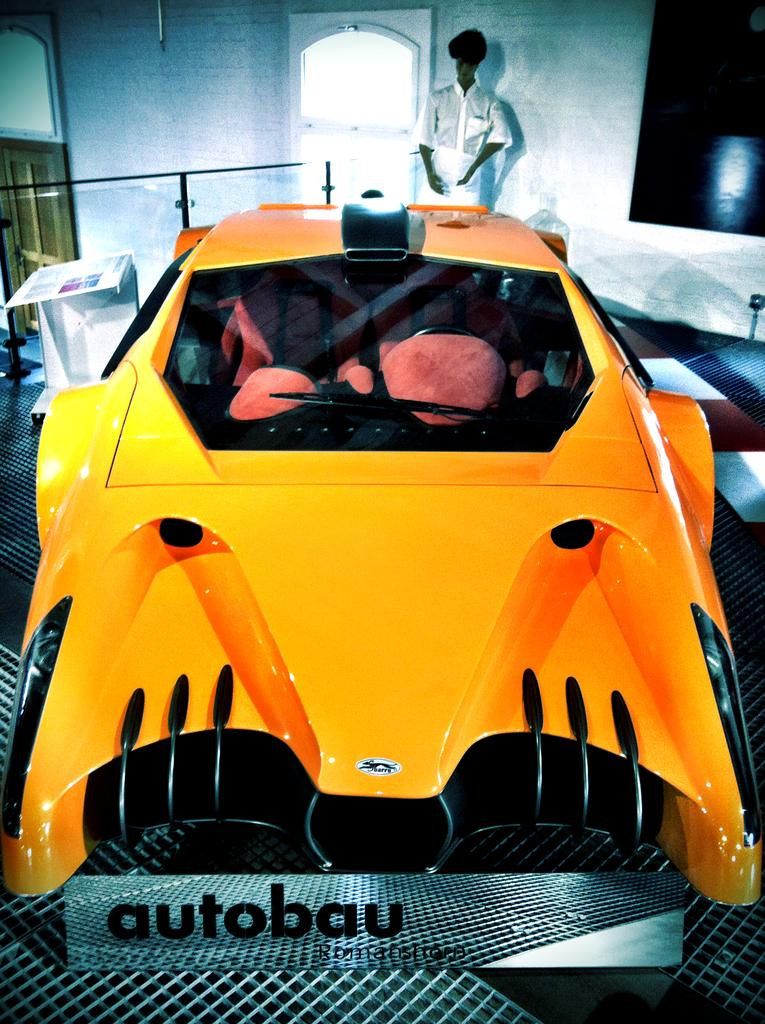What is the main subject in the center of the image? There is a car in the center of the image. Can you describe any other objects or features in the image? There is a door in the image. Where is the man located in the image? The man is at the top side of the image. What type of cup can be seen in the cemetery in the image? There is no cemetery or cup present in the image. What type of building is visible in the image? The provided facts do not mention any buildings in the image. 